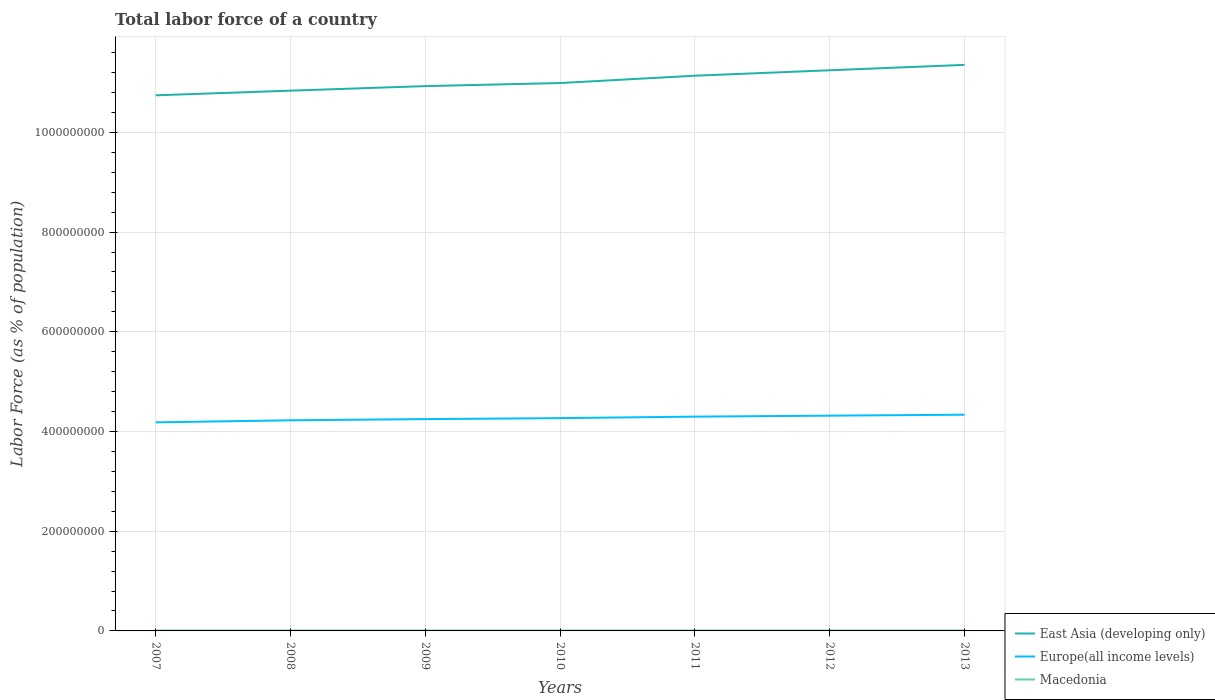How many different coloured lines are there?
Your response must be concise. 3. Does the line corresponding to East Asia (developing only) intersect with the line corresponding to Macedonia?
Your answer should be very brief. No. Is the number of lines equal to the number of legend labels?
Provide a succinct answer. Yes. Across all years, what is the maximum percentage of labor force in Europe(all income levels)?
Give a very brief answer. 4.18e+08. In which year was the percentage of labor force in Europe(all income levels) maximum?
Offer a terse response. 2007. What is the total percentage of labor force in Europe(all income levels) in the graph?
Ensure brevity in your answer.  -1.97e+06. What is the difference between the highest and the second highest percentage of labor force in East Asia (developing only)?
Your answer should be very brief. 6.11e+07. What is the difference between the highest and the lowest percentage of labor force in Europe(all income levels)?
Offer a terse response. 4. Is the percentage of labor force in Macedonia strictly greater than the percentage of labor force in East Asia (developing only) over the years?
Provide a short and direct response. Yes. How many years are there in the graph?
Keep it short and to the point. 7. What is the difference between two consecutive major ticks on the Y-axis?
Make the answer very short. 2.00e+08. Are the values on the major ticks of Y-axis written in scientific E-notation?
Offer a terse response. No. Does the graph contain grids?
Your answer should be compact. Yes. Where does the legend appear in the graph?
Give a very brief answer. Bottom right. How many legend labels are there?
Offer a very short reply. 3. How are the legend labels stacked?
Provide a succinct answer. Vertical. What is the title of the graph?
Give a very brief answer. Total labor force of a country. Does "Czech Republic" appear as one of the legend labels in the graph?
Provide a succinct answer. No. What is the label or title of the X-axis?
Provide a short and direct response. Years. What is the label or title of the Y-axis?
Ensure brevity in your answer.  Labor Force (as % of population). What is the Labor Force (as % of population) in East Asia (developing only) in 2007?
Provide a short and direct response. 1.07e+09. What is the Labor Force (as % of population) in Europe(all income levels) in 2007?
Give a very brief answer. 4.18e+08. What is the Labor Force (as % of population) in Macedonia in 2007?
Provide a short and direct response. 9.01e+05. What is the Labor Force (as % of population) in East Asia (developing only) in 2008?
Your answer should be compact. 1.08e+09. What is the Labor Force (as % of population) in Europe(all income levels) in 2008?
Your answer should be compact. 4.22e+08. What is the Labor Force (as % of population) of Macedonia in 2008?
Offer a very short reply. 9.18e+05. What is the Labor Force (as % of population) in East Asia (developing only) in 2009?
Offer a terse response. 1.09e+09. What is the Labor Force (as % of population) in Europe(all income levels) in 2009?
Your answer should be very brief. 4.25e+08. What is the Labor Force (as % of population) of Macedonia in 2009?
Give a very brief answer. 9.29e+05. What is the Labor Force (as % of population) of East Asia (developing only) in 2010?
Make the answer very short. 1.10e+09. What is the Labor Force (as % of population) in Europe(all income levels) in 2010?
Provide a short and direct response. 4.27e+08. What is the Labor Force (as % of population) of Macedonia in 2010?
Provide a succinct answer. 9.39e+05. What is the Labor Force (as % of population) of East Asia (developing only) in 2011?
Provide a succinct answer. 1.11e+09. What is the Labor Force (as % of population) in Europe(all income levels) in 2011?
Keep it short and to the point. 4.30e+08. What is the Labor Force (as % of population) in Macedonia in 2011?
Offer a very short reply. 9.41e+05. What is the Labor Force (as % of population) of East Asia (developing only) in 2012?
Your response must be concise. 1.12e+09. What is the Labor Force (as % of population) of Europe(all income levels) in 2012?
Ensure brevity in your answer.  4.32e+08. What is the Labor Force (as % of population) of Macedonia in 2012?
Offer a terse response. 9.40e+05. What is the Labor Force (as % of population) in East Asia (developing only) in 2013?
Keep it short and to the point. 1.14e+09. What is the Labor Force (as % of population) of Europe(all income levels) in 2013?
Keep it short and to the point. 4.34e+08. What is the Labor Force (as % of population) in Macedonia in 2013?
Keep it short and to the point. 9.46e+05. Across all years, what is the maximum Labor Force (as % of population) of East Asia (developing only)?
Provide a short and direct response. 1.14e+09. Across all years, what is the maximum Labor Force (as % of population) of Europe(all income levels)?
Provide a succinct answer. 4.34e+08. Across all years, what is the maximum Labor Force (as % of population) in Macedonia?
Make the answer very short. 9.46e+05. Across all years, what is the minimum Labor Force (as % of population) in East Asia (developing only)?
Ensure brevity in your answer.  1.07e+09. Across all years, what is the minimum Labor Force (as % of population) in Europe(all income levels)?
Keep it short and to the point. 4.18e+08. Across all years, what is the minimum Labor Force (as % of population) of Macedonia?
Keep it short and to the point. 9.01e+05. What is the total Labor Force (as % of population) of East Asia (developing only) in the graph?
Your answer should be very brief. 7.72e+09. What is the total Labor Force (as % of population) of Europe(all income levels) in the graph?
Your answer should be very brief. 2.99e+09. What is the total Labor Force (as % of population) of Macedonia in the graph?
Offer a very short reply. 6.51e+06. What is the difference between the Labor Force (as % of population) in East Asia (developing only) in 2007 and that in 2008?
Ensure brevity in your answer.  -9.36e+06. What is the difference between the Labor Force (as % of population) of Europe(all income levels) in 2007 and that in 2008?
Provide a short and direct response. -4.15e+06. What is the difference between the Labor Force (as % of population) of Macedonia in 2007 and that in 2008?
Offer a terse response. -1.70e+04. What is the difference between the Labor Force (as % of population) in East Asia (developing only) in 2007 and that in 2009?
Provide a succinct answer. -1.85e+07. What is the difference between the Labor Force (as % of population) in Europe(all income levels) in 2007 and that in 2009?
Offer a very short reply. -6.53e+06. What is the difference between the Labor Force (as % of population) of Macedonia in 2007 and that in 2009?
Offer a very short reply. -2.87e+04. What is the difference between the Labor Force (as % of population) in East Asia (developing only) in 2007 and that in 2010?
Your answer should be compact. -2.46e+07. What is the difference between the Labor Force (as % of population) of Europe(all income levels) in 2007 and that in 2010?
Ensure brevity in your answer.  -8.50e+06. What is the difference between the Labor Force (as % of population) in Macedonia in 2007 and that in 2010?
Offer a very short reply. -3.79e+04. What is the difference between the Labor Force (as % of population) in East Asia (developing only) in 2007 and that in 2011?
Your answer should be compact. -3.93e+07. What is the difference between the Labor Force (as % of population) of Europe(all income levels) in 2007 and that in 2011?
Provide a succinct answer. -1.15e+07. What is the difference between the Labor Force (as % of population) in Macedonia in 2007 and that in 2011?
Make the answer very short. -4.03e+04. What is the difference between the Labor Force (as % of population) of East Asia (developing only) in 2007 and that in 2012?
Offer a very short reply. -5.03e+07. What is the difference between the Labor Force (as % of population) in Europe(all income levels) in 2007 and that in 2012?
Offer a very short reply. -1.35e+07. What is the difference between the Labor Force (as % of population) of Macedonia in 2007 and that in 2012?
Offer a terse response. -3.97e+04. What is the difference between the Labor Force (as % of population) in East Asia (developing only) in 2007 and that in 2013?
Make the answer very short. -6.11e+07. What is the difference between the Labor Force (as % of population) of Europe(all income levels) in 2007 and that in 2013?
Your answer should be very brief. -1.54e+07. What is the difference between the Labor Force (as % of population) of Macedonia in 2007 and that in 2013?
Offer a terse response. -4.51e+04. What is the difference between the Labor Force (as % of population) of East Asia (developing only) in 2008 and that in 2009?
Your answer should be very brief. -9.12e+06. What is the difference between the Labor Force (as % of population) in Europe(all income levels) in 2008 and that in 2009?
Provide a succinct answer. -2.38e+06. What is the difference between the Labor Force (as % of population) of Macedonia in 2008 and that in 2009?
Provide a short and direct response. -1.17e+04. What is the difference between the Labor Force (as % of population) of East Asia (developing only) in 2008 and that in 2010?
Provide a short and direct response. -1.53e+07. What is the difference between the Labor Force (as % of population) of Europe(all income levels) in 2008 and that in 2010?
Give a very brief answer. -4.35e+06. What is the difference between the Labor Force (as % of population) in Macedonia in 2008 and that in 2010?
Offer a very short reply. -2.09e+04. What is the difference between the Labor Force (as % of population) in East Asia (developing only) in 2008 and that in 2011?
Keep it short and to the point. -3.00e+07. What is the difference between the Labor Force (as % of population) in Europe(all income levels) in 2008 and that in 2011?
Offer a very short reply. -7.33e+06. What is the difference between the Labor Force (as % of population) of Macedonia in 2008 and that in 2011?
Make the answer very short. -2.32e+04. What is the difference between the Labor Force (as % of population) in East Asia (developing only) in 2008 and that in 2012?
Your answer should be compact. -4.09e+07. What is the difference between the Labor Force (as % of population) in Europe(all income levels) in 2008 and that in 2012?
Provide a short and direct response. -9.30e+06. What is the difference between the Labor Force (as % of population) in Macedonia in 2008 and that in 2012?
Your answer should be compact. -2.27e+04. What is the difference between the Labor Force (as % of population) of East Asia (developing only) in 2008 and that in 2013?
Give a very brief answer. -5.18e+07. What is the difference between the Labor Force (as % of population) in Europe(all income levels) in 2008 and that in 2013?
Offer a terse response. -1.12e+07. What is the difference between the Labor Force (as % of population) of Macedonia in 2008 and that in 2013?
Keep it short and to the point. -2.81e+04. What is the difference between the Labor Force (as % of population) in East Asia (developing only) in 2009 and that in 2010?
Give a very brief answer. -6.16e+06. What is the difference between the Labor Force (as % of population) in Europe(all income levels) in 2009 and that in 2010?
Provide a short and direct response. -1.97e+06. What is the difference between the Labor Force (as % of population) in Macedonia in 2009 and that in 2010?
Give a very brief answer. -9234. What is the difference between the Labor Force (as % of population) of East Asia (developing only) in 2009 and that in 2011?
Offer a very short reply. -2.09e+07. What is the difference between the Labor Force (as % of population) in Europe(all income levels) in 2009 and that in 2011?
Your answer should be very brief. -4.95e+06. What is the difference between the Labor Force (as % of population) of Macedonia in 2009 and that in 2011?
Ensure brevity in your answer.  -1.16e+04. What is the difference between the Labor Force (as % of population) of East Asia (developing only) in 2009 and that in 2012?
Your response must be concise. -3.18e+07. What is the difference between the Labor Force (as % of population) of Europe(all income levels) in 2009 and that in 2012?
Ensure brevity in your answer.  -6.92e+06. What is the difference between the Labor Force (as % of population) of Macedonia in 2009 and that in 2012?
Offer a terse response. -1.10e+04. What is the difference between the Labor Force (as % of population) of East Asia (developing only) in 2009 and that in 2013?
Give a very brief answer. -4.26e+07. What is the difference between the Labor Force (as % of population) in Europe(all income levels) in 2009 and that in 2013?
Offer a very short reply. -8.85e+06. What is the difference between the Labor Force (as % of population) in Macedonia in 2009 and that in 2013?
Ensure brevity in your answer.  -1.65e+04. What is the difference between the Labor Force (as % of population) of East Asia (developing only) in 2010 and that in 2011?
Ensure brevity in your answer.  -1.47e+07. What is the difference between the Labor Force (as % of population) of Europe(all income levels) in 2010 and that in 2011?
Give a very brief answer. -2.99e+06. What is the difference between the Labor Force (as % of population) of Macedonia in 2010 and that in 2011?
Your response must be concise. -2328. What is the difference between the Labor Force (as % of population) of East Asia (developing only) in 2010 and that in 2012?
Keep it short and to the point. -2.56e+07. What is the difference between the Labor Force (as % of population) in Europe(all income levels) in 2010 and that in 2012?
Provide a succinct answer. -4.95e+06. What is the difference between the Labor Force (as % of population) in Macedonia in 2010 and that in 2012?
Provide a short and direct response. -1772. What is the difference between the Labor Force (as % of population) in East Asia (developing only) in 2010 and that in 2013?
Keep it short and to the point. -3.65e+07. What is the difference between the Labor Force (as % of population) of Europe(all income levels) in 2010 and that in 2013?
Keep it short and to the point. -6.88e+06. What is the difference between the Labor Force (as % of population) in Macedonia in 2010 and that in 2013?
Offer a very short reply. -7217. What is the difference between the Labor Force (as % of population) in East Asia (developing only) in 2011 and that in 2012?
Your response must be concise. -1.09e+07. What is the difference between the Labor Force (as % of population) in Europe(all income levels) in 2011 and that in 2012?
Provide a succinct answer. -1.97e+06. What is the difference between the Labor Force (as % of population) in Macedonia in 2011 and that in 2012?
Keep it short and to the point. 556. What is the difference between the Labor Force (as % of population) in East Asia (developing only) in 2011 and that in 2013?
Keep it short and to the point. -2.18e+07. What is the difference between the Labor Force (as % of population) of Europe(all income levels) in 2011 and that in 2013?
Give a very brief answer. -3.89e+06. What is the difference between the Labor Force (as % of population) of Macedonia in 2011 and that in 2013?
Your response must be concise. -4889. What is the difference between the Labor Force (as % of population) in East Asia (developing only) in 2012 and that in 2013?
Provide a succinct answer. -1.08e+07. What is the difference between the Labor Force (as % of population) of Europe(all income levels) in 2012 and that in 2013?
Your answer should be very brief. -1.93e+06. What is the difference between the Labor Force (as % of population) of Macedonia in 2012 and that in 2013?
Offer a terse response. -5445. What is the difference between the Labor Force (as % of population) of East Asia (developing only) in 2007 and the Labor Force (as % of population) of Europe(all income levels) in 2008?
Provide a succinct answer. 6.52e+08. What is the difference between the Labor Force (as % of population) in East Asia (developing only) in 2007 and the Labor Force (as % of population) in Macedonia in 2008?
Provide a short and direct response. 1.07e+09. What is the difference between the Labor Force (as % of population) of Europe(all income levels) in 2007 and the Labor Force (as % of population) of Macedonia in 2008?
Provide a short and direct response. 4.17e+08. What is the difference between the Labor Force (as % of population) of East Asia (developing only) in 2007 and the Labor Force (as % of population) of Europe(all income levels) in 2009?
Provide a short and direct response. 6.49e+08. What is the difference between the Labor Force (as % of population) in East Asia (developing only) in 2007 and the Labor Force (as % of population) in Macedonia in 2009?
Ensure brevity in your answer.  1.07e+09. What is the difference between the Labor Force (as % of population) of Europe(all income levels) in 2007 and the Labor Force (as % of population) of Macedonia in 2009?
Your answer should be compact. 4.17e+08. What is the difference between the Labor Force (as % of population) in East Asia (developing only) in 2007 and the Labor Force (as % of population) in Europe(all income levels) in 2010?
Your response must be concise. 6.48e+08. What is the difference between the Labor Force (as % of population) in East Asia (developing only) in 2007 and the Labor Force (as % of population) in Macedonia in 2010?
Make the answer very short. 1.07e+09. What is the difference between the Labor Force (as % of population) of Europe(all income levels) in 2007 and the Labor Force (as % of population) of Macedonia in 2010?
Offer a very short reply. 4.17e+08. What is the difference between the Labor Force (as % of population) of East Asia (developing only) in 2007 and the Labor Force (as % of population) of Europe(all income levels) in 2011?
Provide a succinct answer. 6.45e+08. What is the difference between the Labor Force (as % of population) in East Asia (developing only) in 2007 and the Labor Force (as % of population) in Macedonia in 2011?
Make the answer very short. 1.07e+09. What is the difference between the Labor Force (as % of population) in Europe(all income levels) in 2007 and the Labor Force (as % of population) in Macedonia in 2011?
Make the answer very short. 4.17e+08. What is the difference between the Labor Force (as % of population) in East Asia (developing only) in 2007 and the Labor Force (as % of population) in Europe(all income levels) in 2012?
Provide a short and direct response. 6.43e+08. What is the difference between the Labor Force (as % of population) in East Asia (developing only) in 2007 and the Labor Force (as % of population) in Macedonia in 2012?
Ensure brevity in your answer.  1.07e+09. What is the difference between the Labor Force (as % of population) of Europe(all income levels) in 2007 and the Labor Force (as % of population) of Macedonia in 2012?
Keep it short and to the point. 4.17e+08. What is the difference between the Labor Force (as % of population) in East Asia (developing only) in 2007 and the Labor Force (as % of population) in Europe(all income levels) in 2013?
Your answer should be compact. 6.41e+08. What is the difference between the Labor Force (as % of population) of East Asia (developing only) in 2007 and the Labor Force (as % of population) of Macedonia in 2013?
Provide a short and direct response. 1.07e+09. What is the difference between the Labor Force (as % of population) of Europe(all income levels) in 2007 and the Labor Force (as % of population) of Macedonia in 2013?
Offer a terse response. 4.17e+08. What is the difference between the Labor Force (as % of population) of East Asia (developing only) in 2008 and the Labor Force (as % of population) of Europe(all income levels) in 2009?
Offer a very short reply. 6.59e+08. What is the difference between the Labor Force (as % of population) of East Asia (developing only) in 2008 and the Labor Force (as % of population) of Macedonia in 2009?
Offer a very short reply. 1.08e+09. What is the difference between the Labor Force (as % of population) in Europe(all income levels) in 2008 and the Labor Force (as % of population) in Macedonia in 2009?
Offer a very short reply. 4.22e+08. What is the difference between the Labor Force (as % of population) of East Asia (developing only) in 2008 and the Labor Force (as % of population) of Europe(all income levels) in 2010?
Your response must be concise. 6.57e+08. What is the difference between the Labor Force (as % of population) of East Asia (developing only) in 2008 and the Labor Force (as % of population) of Macedonia in 2010?
Keep it short and to the point. 1.08e+09. What is the difference between the Labor Force (as % of population) of Europe(all income levels) in 2008 and the Labor Force (as % of population) of Macedonia in 2010?
Make the answer very short. 4.22e+08. What is the difference between the Labor Force (as % of population) in East Asia (developing only) in 2008 and the Labor Force (as % of population) in Europe(all income levels) in 2011?
Offer a very short reply. 6.54e+08. What is the difference between the Labor Force (as % of population) in East Asia (developing only) in 2008 and the Labor Force (as % of population) in Macedonia in 2011?
Provide a succinct answer. 1.08e+09. What is the difference between the Labor Force (as % of population) in Europe(all income levels) in 2008 and the Labor Force (as % of population) in Macedonia in 2011?
Make the answer very short. 4.22e+08. What is the difference between the Labor Force (as % of population) in East Asia (developing only) in 2008 and the Labor Force (as % of population) in Europe(all income levels) in 2012?
Your answer should be very brief. 6.52e+08. What is the difference between the Labor Force (as % of population) in East Asia (developing only) in 2008 and the Labor Force (as % of population) in Macedonia in 2012?
Make the answer very short. 1.08e+09. What is the difference between the Labor Force (as % of population) of Europe(all income levels) in 2008 and the Labor Force (as % of population) of Macedonia in 2012?
Ensure brevity in your answer.  4.22e+08. What is the difference between the Labor Force (as % of population) in East Asia (developing only) in 2008 and the Labor Force (as % of population) in Europe(all income levels) in 2013?
Make the answer very short. 6.50e+08. What is the difference between the Labor Force (as % of population) of East Asia (developing only) in 2008 and the Labor Force (as % of population) of Macedonia in 2013?
Provide a short and direct response. 1.08e+09. What is the difference between the Labor Force (as % of population) of Europe(all income levels) in 2008 and the Labor Force (as % of population) of Macedonia in 2013?
Offer a terse response. 4.22e+08. What is the difference between the Labor Force (as % of population) of East Asia (developing only) in 2009 and the Labor Force (as % of population) of Europe(all income levels) in 2010?
Give a very brief answer. 6.66e+08. What is the difference between the Labor Force (as % of population) in East Asia (developing only) in 2009 and the Labor Force (as % of population) in Macedonia in 2010?
Ensure brevity in your answer.  1.09e+09. What is the difference between the Labor Force (as % of population) in Europe(all income levels) in 2009 and the Labor Force (as % of population) in Macedonia in 2010?
Keep it short and to the point. 4.24e+08. What is the difference between the Labor Force (as % of population) in East Asia (developing only) in 2009 and the Labor Force (as % of population) in Europe(all income levels) in 2011?
Keep it short and to the point. 6.63e+08. What is the difference between the Labor Force (as % of population) in East Asia (developing only) in 2009 and the Labor Force (as % of population) in Macedonia in 2011?
Provide a short and direct response. 1.09e+09. What is the difference between the Labor Force (as % of population) in Europe(all income levels) in 2009 and the Labor Force (as % of population) in Macedonia in 2011?
Your answer should be compact. 4.24e+08. What is the difference between the Labor Force (as % of population) of East Asia (developing only) in 2009 and the Labor Force (as % of population) of Europe(all income levels) in 2012?
Offer a terse response. 6.61e+08. What is the difference between the Labor Force (as % of population) of East Asia (developing only) in 2009 and the Labor Force (as % of population) of Macedonia in 2012?
Ensure brevity in your answer.  1.09e+09. What is the difference between the Labor Force (as % of population) of Europe(all income levels) in 2009 and the Labor Force (as % of population) of Macedonia in 2012?
Ensure brevity in your answer.  4.24e+08. What is the difference between the Labor Force (as % of population) in East Asia (developing only) in 2009 and the Labor Force (as % of population) in Europe(all income levels) in 2013?
Give a very brief answer. 6.59e+08. What is the difference between the Labor Force (as % of population) in East Asia (developing only) in 2009 and the Labor Force (as % of population) in Macedonia in 2013?
Your answer should be compact. 1.09e+09. What is the difference between the Labor Force (as % of population) in Europe(all income levels) in 2009 and the Labor Force (as % of population) in Macedonia in 2013?
Offer a very short reply. 4.24e+08. What is the difference between the Labor Force (as % of population) of East Asia (developing only) in 2010 and the Labor Force (as % of population) of Europe(all income levels) in 2011?
Your answer should be compact. 6.69e+08. What is the difference between the Labor Force (as % of population) in East Asia (developing only) in 2010 and the Labor Force (as % of population) in Macedonia in 2011?
Give a very brief answer. 1.10e+09. What is the difference between the Labor Force (as % of population) in Europe(all income levels) in 2010 and the Labor Force (as % of population) in Macedonia in 2011?
Keep it short and to the point. 4.26e+08. What is the difference between the Labor Force (as % of population) of East Asia (developing only) in 2010 and the Labor Force (as % of population) of Europe(all income levels) in 2012?
Give a very brief answer. 6.67e+08. What is the difference between the Labor Force (as % of population) in East Asia (developing only) in 2010 and the Labor Force (as % of population) in Macedonia in 2012?
Make the answer very short. 1.10e+09. What is the difference between the Labor Force (as % of population) of Europe(all income levels) in 2010 and the Labor Force (as % of population) of Macedonia in 2012?
Provide a succinct answer. 4.26e+08. What is the difference between the Labor Force (as % of population) in East Asia (developing only) in 2010 and the Labor Force (as % of population) in Europe(all income levels) in 2013?
Offer a very short reply. 6.65e+08. What is the difference between the Labor Force (as % of population) of East Asia (developing only) in 2010 and the Labor Force (as % of population) of Macedonia in 2013?
Your answer should be compact. 1.10e+09. What is the difference between the Labor Force (as % of population) of Europe(all income levels) in 2010 and the Labor Force (as % of population) of Macedonia in 2013?
Offer a terse response. 4.26e+08. What is the difference between the Labor Force (as % of population) in East Asia (developing only) in 2011 and the Labor Force (as % of population) in Europe(all income levels) in 2012?
Provide a succinct answer. 6.82e+08. What is the difference between the Labor Force (as % of population) of East Asia (developing only) in 2011 and the Labor Force (as % of population) of Macedonia in 2012?
Your answer should be very brief. 1.11e+09. What is the difference between the Labor Force (as % of population) in Europe(all income levels) in 2011 and the Labor Force (as % of population) in Macedonia in 2012?
Your answer should be compact. 4.29e+08. What is the difference between the Labor Force (as % of population) of East Asia (developing only) in 2011 and the Labor Force (as % of population) of Europe(all income levels) in 2013?
Your answer should be compact. 6.80e+08. What is the difference between the Labor Force (as % of population) in East Asia (developing only) in 2011 and the Labor Force (as % of population) in Macedonia in 2013?
Keep it short and to the point. 1.11e+09. What is the difference between the Labor Force (as % of population) in Europe(all income levels) in 2011 and the Labor Force (as % of population) in Macedonia in 2013?
Your answer should be very brief. 4.29e+08. What is the difference between the Labor Force (as % of population) in East Asia (developing only) in 2012 and the Labor Force (as % of population) in Europe(all income levels) in 2013?
Give a very brief answer. 6.91e+08. What is the difference between the Labor Force (as % of population) of East Asia (developing only) in 2012 and the Labor Force (as % of population) of Macedonia in 2013?
Your response must be concise. 1.12e+09. What is the difference between the Labor Force (as % of population) of Europe(all income levels) in 2012 and the Labor Force (as % of population) of Macedonia in 2013?
Give a very brief answer. 4.31e+08. What is the average Labor Force (as % of population) of East Asia (developing only) per year?
Your answer should be compact. 1.10e+09. What is the average Labor Force (as % of population) in Europe(all income levels) per year?
Make the answer very short. 4.27e+08. What is the average Labor Force (as % of population) in Macedonia per year?
Offer a very short reply. 9.30e+05. In the year 2007, what is the difference between the Labor Force (as % of population) of East Asia (developing only) and Labor Force (as % of population) of Europe(all income levels)?
Your answer should be very brief. 6.56e+08. In the year 2007, what is the difference between the Labor Force (as % of population) in East Asia (developing only) and Labor Force (as % of population) in Macedonia?
Ensure brevity in your answer.  1.07e+09. In the year 2007, what is the difference between the Labor Force (as % of population) of Europe(all income levels) and Labor Force (as % of population) of Macedonia?
Make the answer very short. 4.17e+08. In the year 2008, what is the difference between the Labor Force (as % of population) in East Asia (developing only) and Labor Force (as % of population) in Europe(all income levels)?
Keep it short and to the point. 6.61e+08. In the year 2008, what is the difference between the Labor Force (as % of population) in East Asia (developing only) and Labor Force (as % of population) in Macedonia?
Make the answer very short. 1.08e+09. In the year 2008, what is the difference between the Labor Force (as % of population) in Europe(all income levels) and Labor Force (as % of population) in Macedonia?
Give a very brief answer. 4.22e+08. In the year 2009, what is the difference between the Labor Force (as % of population) in East Asia (developing only) and Labor Force (as % of population) in Europe(all income levels)?
Keep it short and to the point. 6.68e+08. In the year 2009, what is the difference between the Labor Force (as % of population) in East Asia (developing only) and Labor Force (as % of population) in Macedonia?
Offer a terse response. 1.09e+09. In the year 2009, what is the difference between the Labor Force (as % of population) in Europe(all income levels) and Labor Force (as % of population) in Macedonia?
Your response must be concise. 4.24e+08. In the year 2010, what is the difference between the Labor Force (as % of population) in East Asia (developing only) and Labor Force (as % of population) in Europe(all income levels)?
Offer a terse response. 6.72e+08. In the year 2010, what is the difference between the Labor Force (as % of population) in East Asia (developing only) and Labor Force (as % of population) in Macedonia?
Your response must be concise. 1.10e+09. In the year 2010, what is the difference between the Labor Force (as % of population) in Europe(all income levels) and Labor Force (as % of population) in Macedonia?
Offer a very short reply. 4.26e+08. In the year 2011, what is the difference between the Labor Force (as % of population) of East Asia (developing only) and Labor Force (as % of population) of Europe(all income levels)?
Keep it short and to the point. 6.84e+08. In the year 2011, what is the difference between the Labor Force (as % of population) in East Asia (developing only) and Labor Force (as % of population) in Macedonia?
Your response must be concise. 1.11e+09. In the year 2011, what is the difference between the Labor Force (as % of population) in Europe(all income levels) and Labor Force (as % of population) in Macedonia?
Offer a very short reply. 4.29e+08. In the year 2012, what is the difference between the Labor Force (as % of population) in East Asia (developing only) and Labor Force (as % of population) in Europe(all income levels)?
Your response must be concise. 6.93e+08. In the year 2012, what is the difference between the Labor Force (as % of population) of East Asia (developing only) and Labor Force (as % of population) of Macedonia?
Provide a succinct answer. 1.12e+09. In the year 2012, what is the difference between the Labor Force (as % of population) in Europe(all income levels) and Labor Force (as % of population) in Macedonia?
Make the answer very short. 4.31e+08. In the year 2013, what is the difference between the Labor Force (as % of population) in East Asia (developing only) and Labor Force (as % of population) in Europe(all income levels)?
Give a very brief answer. 7.02e+08. In the year 2013, what is the difference between the Labor Force (as % of population) of East Asia (developing only) and Labor Force (as % of population) of Macedonia?
Provide a short and direct response. 1.13e+09. In the year 2013, what is the difference between the Labor Force (as % of population) in Europe(all income levels) and Labor Force (as % of population) in Macedonia?
Keep it short and to the point. 4.33e+08. What is the ratio of the Labor Force (as % of population) in Europe(all income levels) in 2007 to that in 2008?
Keep it short and to the point. 0.99. What is the ratio of the Labor Force (as % of population) in Macedonia in 2007 to that in 2008?
Ensure brevity in your answer.  0.98. What is the ratio of the Labor Force (as % of population) in East Asia (developing only) in 2007 to that in 2009?
Ensure brevity in your answer.  0.98. What is the ratio of the Labor Force (as % of population) in Europe(all income levels) in 2007 to that in 2009?
Keep it short and to the point. 0.98. What is the ratio of the Labor Force (as % of population) of Macedonia in 2007 to that in 2009?
Offer a terse response. 0.97. What is the ratio of the Labor Force (as % of population) in East Asia (developing only) in 2007 to that in 2010?
Keep it short and to the point. 0.98. What is the ratio of the Labor Force (as % of population) in Europe(all income levels) in 2007 to that in 2010?
Provide a short and direct response. 0.98. What is the ratio of the Labor Force (as % of population) in Macedonia in 2007 to that in 2010?
Offer a very short reply. 0.96. What is the ratio of the Labor Force (as % of population) in East Asia (developing only) in 2007 to that in 2011?
Offer a very short reply. 0.96. What is the ratio of the Labor Force (as % of population) of Europe(all income levels) in 2007 to that in 2011?
Make the answer very short. 0.97. What is the ratio of the Labor Force (as % of population) in Macedonia in 2007 to that in 2011?
Provide a succinct answer. 0.96. What is the ratio of the Labor Force (as % of population) in East Asia (developing only) in 2007 to that in 2012?
Offer a terse response. 0.96. What is the ratio of the Labor Force (as % of population) in Europe(all income levels) in 2007 to that in 2012?
Give a very brief answer. 0.97. What is the ratio of the Labor Force (as % of population) in Macedonia in 2007 to that in 2012?
Ensure brevity in your answer.  0.96. What is the ratio of the Labor Force (as % of population) in East Asia (developing only) in 2007 to that in 2013?
Provide a short and direct response. 0.95. What is the ratio of the Labor Force (as % of population) of Europe(all income levels) in 2007 to that in 2013?
Ensure brevity in your answer.  0.96. What is the ratio of the Labor Force (as % of population) of Macedonia in 2007 to that in 2013?
Your response must be concise. 0.95. What is the ratio of the Labor Force (as % of population) of East Asia (developing only) in 2008 to that in 2009?
Make the answer very short. 0.99. What is the ratio of the Labor Force (as % of population) of Europe(all income levels) in 2008 to that in 2009?
Your response must be concise. 0.99. What is the ratio of the Labor Force (as % of population) of Macedonia in 2008 to that in 2009?
Keep it short and to the point. 0.99. What is the ratio of the Labor Force (as % of population) of East Asia (developing only) in 2008 to that in 2010?
Keep it short and to the point. 0.99. What is the ratio of the Labor Force (as % of population) of Macedonia in 2008 to that in 2010?
Provide a succinct answer. 0.98. What is the ratio of the Labor Force (as % of population) of East Asia (developing only) in 2008 to that in 2011?
Provide a succinct answer. 0.97. What is the ratio of the Labor Force (as % of population) of Europe(all income levels) in 2008 to that in 2011?
Give a very brief answer. 0.98. What is the ratio of the Labor Force (as % of population) of Macedonia in 2008 to that in 2011?
Keep it short and to the point. 0.98. What is the ratio of the Labor Force (as % of population) of East Asia (developing only) in 2008 to that in 2012?
Ensure brevity in your answer.  0.96. What is the ratio of the Labor Force (as % of population) of Europe(all income levels) in 2008 to that in 2012?
Provide a short and direct response. 0.98. What is the ratio of the Labor Force (as % of population) of Macedonia in 2008 to that in 2012?
Provide a short and direct response. 0.98. What is the ratio of the Labor Force (as % of population) of East Asia (developing only) in 2008 to that in 2013?
Give a very brief answer. 0.95. What is the ratio of the Labor Force (as % of population) of Europe(all income levels) in 2008 to that in 2013?
Provide a short and direct response. 0.97. What is the ratio of the Labor Force (as % of population) in Macedonia in 2008 to that in 2013?
Your answer should be very brief. 0.97. What is the ratio of the Labor Force (as % of population) of Macedonia in 2009 to that in 2010?
Give a very brief answer. 0.99. What is the ratio of the Labor Force (as % of population) of East Asia (developing only) in 2009 to that in 2011?
Keep it short and to the point. 0.98. What is the ratio of the Labor Force (as % of population) in East Asia (developing only) in 2009 to that in 2012?
Give a very brief answer. 0.97. What is the ratio of the Labor Force (as % of population) in Europe(all income levels) in 2009 to that in 2012?
Provide a short and direct response. 0.98. What is the ratio of the Labor Force (as % of population) of Macedonia in 2009 to that in 2012?
Offer a terse response. 0.99. What is the ratio of the Labor Force (as % of population) of East Asia (developing only) in 2009 to that in 2013?
Provide a short and direct response. 0.96. What is the ratio of the Labor Force (as % of population) of Europe(all income levels) in 2009 to that in 2013?
Offer a terse response. 0.98. What is the ratio of the Labor Force (as % of population) of Macedonia in 2009 to that in 2013?
Offer a terse response. 0.98. What is the ratio of the Labor Force (as % of population) in East Asia (developing only) in 2010 to that in 2011?
Provide a succinct answer. 0.99. What is the ratio of the Labor Force (as % of population) of Macedonia in 2010 to that in 2011?
Provide a succinct answer. 1. What is the ratio of the Labor Force (as % of population) in East Asia (developing only) in 2010 to that in 2012?
Give a very brief answer. 0.98. What is the ratio of the Labor Force (as % of population) of Macedonia in 2010 to that in 2012?
Make the answer very short. 1. What is the ratio of the Labor Force (as % of population) of East Asia (developing only) in 2010 to that in 2013?
Give a very brief answer. 0.97. What is the ratio of the Labor Force (as % of population) in Europe(all income levels) in 2010 to that in 2013?
Provide a succinct answer. 0.98. What is the ratio of the Labor Force (as % of population) of Macedonia in 2010 to that in 2013?
Provide a succinct answer. 0.99. What is the ratio of the Labor Force (as % of population) in East Asia (developing only) in 2011 to that in 2012?
Give a very brief answer. 0.99. What is the ratio of the Labor Force (as % of population) of Europe(all income levels) in 2011 to that in 2012?
Ensure brevity in your answer.  1. What is the ratio of the Labor Force (as % of population) of Macedonia in 2011 to that in 2012?
Ensure brevity in your answer.  1. What is the ratio of the Labor Force (as % of population) of East Asia (developing only) in 2011 to that in 2013?
Give a very brief answer. 0.98. What is the ratio of the Labor Force (as % of population) of Europe(all income levels) in 2011 to that in 2013?
Your answer should be compact. 0.99. What is the ratio of the Labor Force (as % of population) of Europe(all income levels) in 2012 to that in 2013?
Offer a very short reply. 1. What is the ratio of the Labor Force (as % of population) of Macedonia in 2012 to that in 2013?
Your answer should be compact. 0.99. What is the difference between the highest and the second highest Labor Force (as % of population) of East Asia (developing only)?
Give a very brief answer. 1.08e+07. What is the difference between the highest and the second highest Labor Force (as % of population) of Europe(all income levels)?
Your answer should be very brief. 1.93e+06. What is the difference between the highest and the second highest Labor Force (as % of population) in Macedonia?
Keep it short and to the point. 4889. What is the difference between the highest and the lowest Labor Force (as % of population) of East Asia (developing only)?
Keep it short and to the point. 6.11e+07. What is the difference between the highest and the lowest Labor Force (as % of population) of Europe(all income levels)?
Provide a succinct answer. 1.54e+07. What is the difference between the highest and the lowest Labor Force (as % of population) in Macedonia?
Make the answer very short. 4.51e+04. 